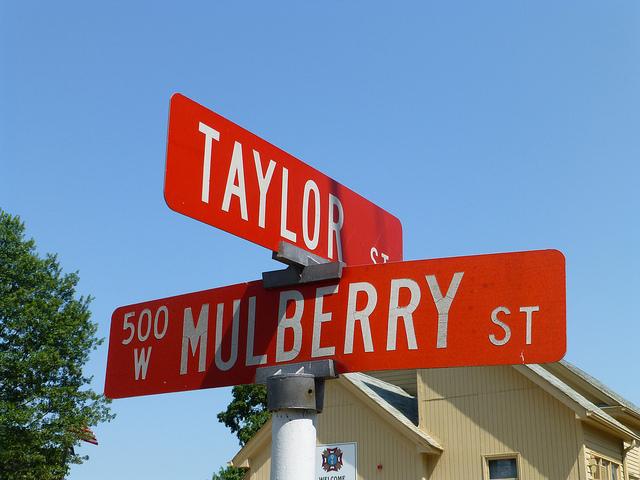What color is the street sign?
Concise answer only. Red. Is this an intersection?
Short answer required. Yes. What city is this intersection in?
Short answer required. New york. What is the street name on the top sign?
Write a very short answer. Taylor. What business is on the building?
Keep it brief. Church. What cross streets are we at?
Write a very short answer. Taylor and mulberry. What color are the street signs?
Short answer required. Red. What is the name of the cross street?
Concise answer only. Taylor. What color are the letters?
Answer briefly. White. Which street name is also a name for a tree?
Write a very short answer. Mulberry. North, south, east, or west?
Write a very short answer. West. What is the first word?
Concise answer only. Taylor. What is the red sign for?
Be succinct. Street. 